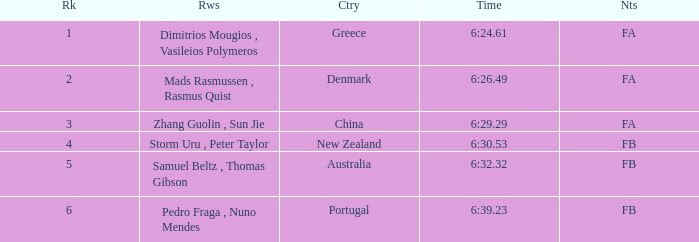What country has a rank smaller than 6, a time of 6:32.32 and notes of FB? Australia. 